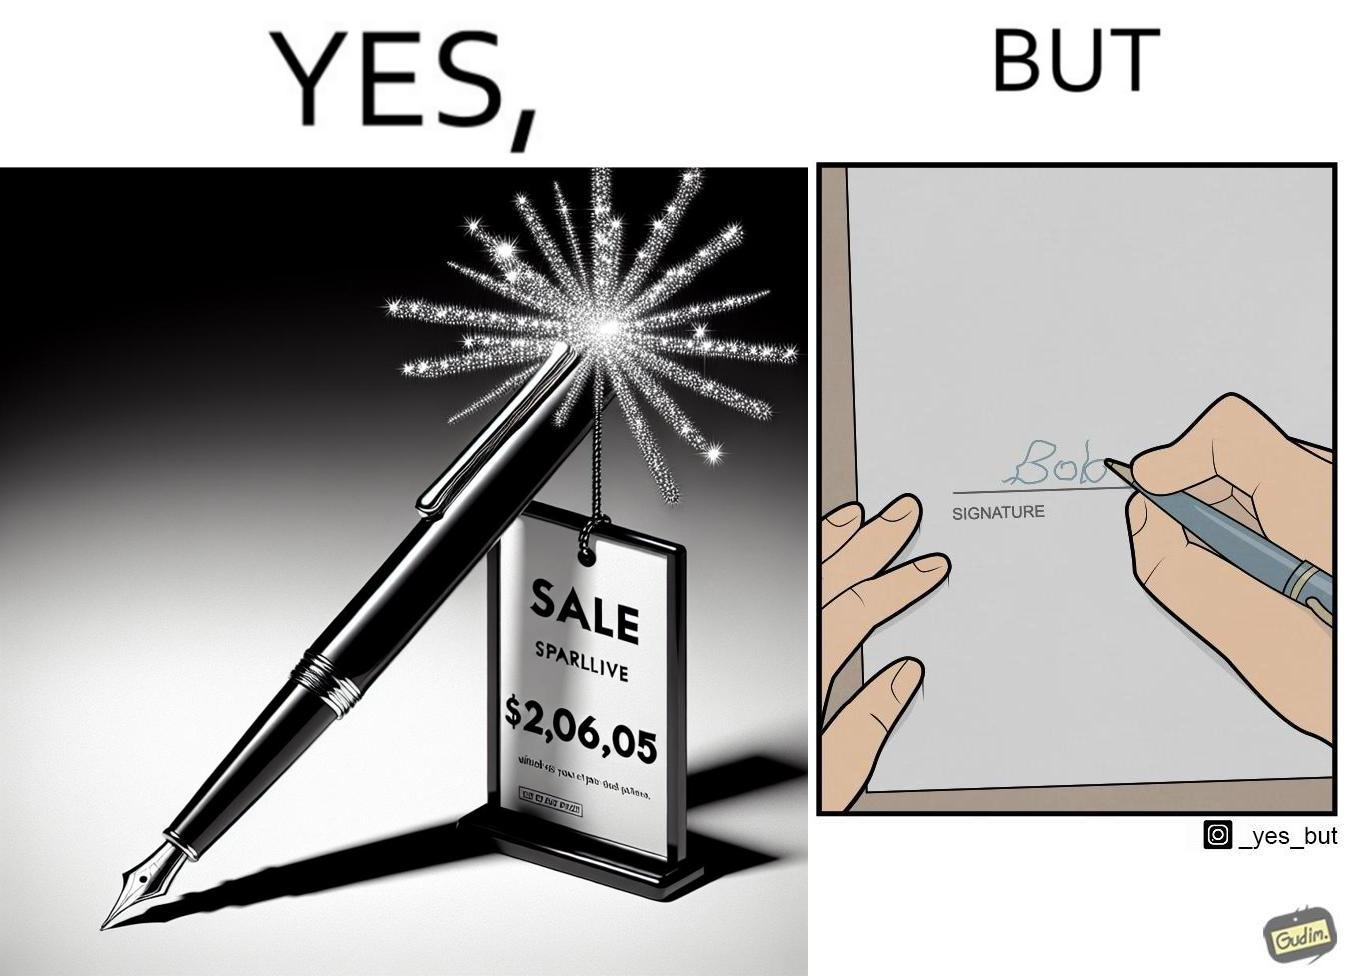Describe the satirical element in this image. The image is ironic, because it conveys the message that even with the costliest of pens people handwriting remains the same 